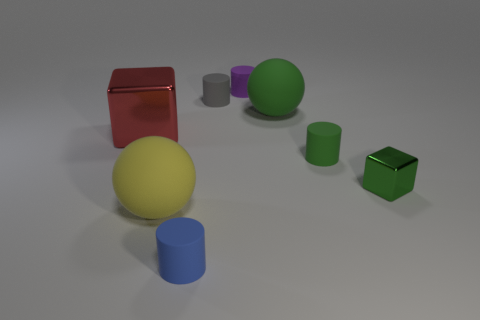Subtract all blue rubber cylinders. How many cylinders are left? 3 Add 1 tiny metal objects. How many objects exist? 9 Subtract all red cubes. How many cubes are left? 1 Subtract 3 cylinders. How many cylinders are left? 1 Subtract all cubes. How many objects are left? 6 Subtract all blue balls. Subtract all blue cylinders. How many balls are left? 2 Subtract all gray cubes. How many green spheres are left? 1 Subtract all big red matte blocks. Subtract all big things. How many objects are left? 5 Add 4 green matte spheres. How many green matte spheres are left? 5 Add 5 small green metallic cubes. How many small green metallic cubes exist? 6 